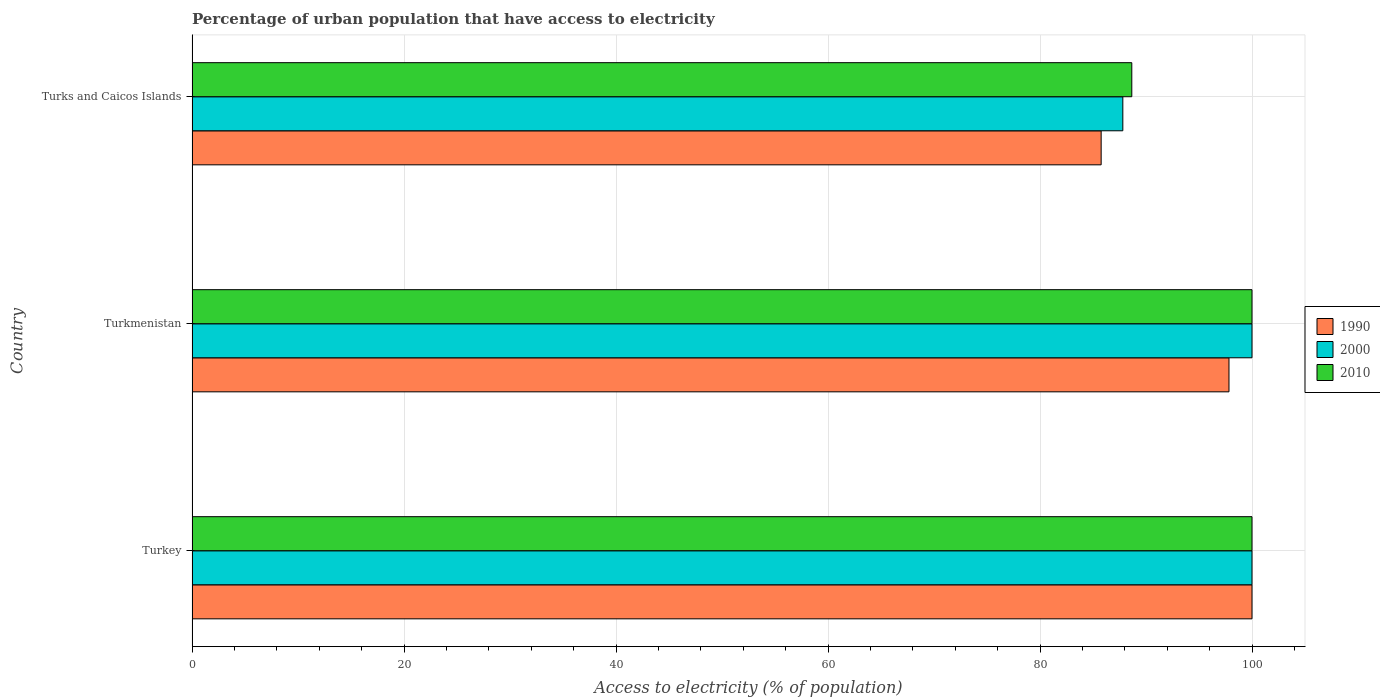How many different coloured bars are there?
Provide a short and direct response. 3. How many groups of bars are there?
Your answer should be very brief. 3. Are the number of bars per tick equal to the number of legend labels?
Provide a succinct answer. Yes. Are the number of bars on each tick of the Y-axis equal?
Offer a very short reply. Yes. How many bars are there on the 3rd tick from the top?
Provide a succinct answer. 3. How many bars are there on the 1st tick from the bottom?
Provide a short and direct response. 3. What is the label of the 1st group of bars from the top?
Your response must be concise. Turks and Caicos Islands. In how many cases, is the number of bars for a given country not equal to the number of legend labels?
Make the answer very short. 0. What is the percentage of urban population that have access to electricity in 1990 in Turks and Caicos Islands?
Your answer should be compact. 85.77. Across all countries, what is the maximum percentage of urban population that have access to electricity in 1990?
Provide a short and direct response. 100. Across all countries, what is the minimum percentage of urban population that have access to electricity in 2010?
Provide a succinct answer. 88.66. In which country was the percentage of urban population that have access to electricity in 2010 minimum?
Give a very brief answer. Turks and Caicos Islands. What is the total percentage of urban population that have access to electricity in 2010 in the graph?
Ensure brevity in your answer.  288.66. What is the difference between the percentage of urban population that have access to electricity in 1990 in Turkmenistan and that in Turks and Caicos Islands?
Your response must be concise. 12.06. What is the difference between the percentage of urban population that have access to electricity in 2000 in Turks and Caicos Islands and the percentage of urban population that have access to electricity in 1990 in Turkey?
Make the answer very short. -12.19. What is the average percentage of urban population that have access to electricity in 2010 per country?
Provide a succinct answer. 96.22. In how many countries, is the percentage of urban population that have access to electricity in 1990 greater than 12 %?
Keep it short and to the point. 3. What is the ratio of the percentage of urban population that have access to electricity in 2010 in Turkey to that in Turks and Caicos Islands?
Your response must be concise. 1.13. Is the difference between the percentage of urban population that have access to electricity in 2010 in Turkey and Turkmenistan greater than the difference between the percentage of urban population that have access to electricity in 2000 in Turkey and Turkmenistan?
Your answer should be compact. No. What is the difference between the highest and the lowest percentage of urban population that have access to electricity in 1990?
Keep it short and to the point. 14.23. Is it the case that in every country, the sum of the percentage of urban population that have access to electricity in 2000 and percentage of urban population that have access to electricity in 1990 is greater than the percentage of urban population that have access to electricity in 2010?
Ensure brevity in your answer.  Yes. How many bars are there?
Your answer should be very brief. 9. What is the difference between two consecutive major ticks on the X-axis?
Your answer should be very brief. 20. Does the graph contain grids?
Your answer should be compact. Yes. Where does the legend appear in the graph?
Offer a very short reply. Center right. What is the title of the graph?
Ensure brevity in your answer.  Percentage of urban population that have access to electricity. What is the label or title of the X-axis?
Keep it short and to the point. Access to electricity (% of population). What is the label or title of the Y-axis?
Offer a terse response. Country. What is the Access to electricity (% of population) in 2000 in Turkey?
Ensure brevity in your answer.  100. What is the Access to electricity (% of population) in 1990 in Turkmenistan?
Ensure brevity in your answer.  97.83. What is the Access to electricity (% of population) in 1990 in Turks and Caicos Islands?
Offer a terse response. 85.77. What is the Access to electricity (% of population) in 2000 in Turks and Caicos Islands?
Offer a terse response. 87.81. What is the Access to electricity (% of population) in 2010 in Turks and Caicos Islands?
Give a very brief answer. 88.66. Across all countries, what is the maximum Access to electricity (% of population) of 1990?
Give a very brief answer. 100. Across all countries, what is the minimum Access to electricity (% of population) of 1990?
Your answer should be very brief. 85.77. Across all countries, what is the minimum Access to electricity (% of population) of 2000?
Offer a very short reply. 87.81. Across all countries, what is the minimum Access to electricity (% of population) in 2010?
Make the answer very short. 88.66. What is the total Access to electricity (% of population) of 1990 in the graph?
Give a very brief answer. 283.6. What is the total Access to electricity (% of population) of 2000 in the graph?
Your answer should be very brief. 287.81. What is the total Access to electricity (% of population) in 2010 in the graph?
Keep it short and to the point. 288.66. What is the difference between the Access to electricity (% of population) in 1990 in Turkey and that in Turkmenistan?
Give a very brief answer. 2.17. What is the difference between the Access to electricity (% of population) in 2000 in Turkey and that in Turkmenistan?
Provide a succinct answer. 0. What is the difference between the Access to electricity (% of population) of 1990 in Turkey and that in Turks and Caicos Islands?
Your answer should be very brief. 14.23. What is the difference between the Access to electricity (% of population) in 2000 in Turkey and that in Turks and Caicos Islands?
Your answer should be very brief. 12.19. What is the difference between the Access to electricity (% of population) of 2010 in Turkey and that in Turks and Caicos Islands?
Provide a succinct answer. 11.34. What is the difference between the Access to electricity (% of population) in 1990 in Turkmenistan and that in Turks and Caicos Islands?
Offer a very short reply. 12.06. What is the difference between the Access to electricity (% of population) of 2000 in Turkmenistan and that in Turks and Caicos Islands?
Your answer should be very brief. 12.19. What is the difference between the Access to electricity (% of population) in 2010 in Turkmenistan and that in Turks and Caicos Islands?
Provide a short and direct response. 11.34. What is the difference between the Access to electricity (% of population) of 1990 in Turkey and the Access to electricity (% of population) of 2000 in Turks and Caicos Islands?
Provide a succinct answer. 12.19. What is the difference between the Access to electricity (% of population) in 1990 in Turkey and the Access to electricity (% of population) in 2010 in Turks and Caicos Islands?
Your answer should be very brief. 11.34. What is the difference between the Access to electricity (% of population) of 2000 in Turkey and the Access to electricity (% of population) of 2010 in Turks and Caicos Islands?
Provide a succinct answer. 11.34. What is the difference between the Access to electricity (% of population) in 1990 in Turkmenistan and the Access to electricity (% of population) in 2000 in Turks and Caicos Islands?
Offer a very short reply. 10.02. What is the difference between the Access to electricity (% of population) in 1990 in Turkmenistan and the Access to electricity (% of population) in 2010 in Turks and Caicos Islands?
Your response must be concise. 9.17. What is the difference between the Access to electricity (% of population) in 2000 in Turkmenistan and the Access to electricity (% of population) in 2010 in Turks and Caicos Islands?
Offer a very short reply. 11.34. What is the average Access to electricity (% of population) of 1990 per country?
Your answer should be very brief. 94.53. What is the average Access to electricity (% of population) in 2000 per country?
Your answer should be very brief. 95.94. What is the average Access to electricity (% of population) in 2010 per country?
Your answer should be compact. 96.22. What is the difference between the Access to electricity (% of population) of 1990 and Access to electricity (% of population) of 2000 in Turkey?
Make the answer very short. 0. What is the difference between the Access to electricity (% of population) of 2000 and Access to electricity (% of population) of 2010 in Turkey?
Your answer should be compact. 0. What is the difference between the Access to electricity (% of population) in 1990 and Access to electricity (% of population) in 2000 in Turkmenistan?
Make the answer very short. -2.17. What is the difference between the Access to electricity (% of population) of 1990 and Access to electricity (% of population) of 2010 in Turkmenistan?
Keep it short and to the point. -2.17. What is the difference between the Access to electricity (% of population) of 2000 and Access to electricity (% of population) of 2010 in Turkmenistan?
Your response must be concise. 0. What is the difference between the Access to electricity (% of population) of 1990 and Access to electricity (% of population) of 2000 in Turks and Caicos Islands?
Your answer should be very brief. -2.04. What is the difference between the Access to electricity (% of population) in 1990 and Access to electricity (% of population) in 2010 in Turks and Caicos Islands?
Offer a very short reply. -2.89. What is the difference between the Access to electricity (% of population) in 2000 and Access to electricity (% of population) in 2010 in Turks and Caicos Islands?
Offer a terse response. -0.85. What is the ratio of the Access to electricity (% of population) in 1990 in Turkey to that in Turkmenistan?
Offer a very short reply. 1.02. What is the ratio of the Access to electricity (% of population) of 2000 in Turkey to that in Turkmenistan?
Ensure brevity in your answer.  1. What is the ratio of the Access to electricity (% of population) in 2010 in Turkey to that in Turkmenistan?
Ensure brevity in your answer.  1. What is the ratio of the Access to electricity (% of population) in 1990 in Turkey to that in Turks and Caicos Islands?
Provide a succinct answer. 1.17. What is the ratio of the Access to electricity (% of population) of 2000 in Turkey to that in Turks and Caicos Islands?
Your answer should be very brief. 1.14. What is the ratio of the Access to electricity (% of population) of 2010 in Turkey to that in Turks and Caicos Islands?
Give a very brief answer. 1.13. What is the ratio of the Access to electricity (% of population) of 1990 in Turkmenistan to that in Turks and Caicos Islands?
Give a very brief answer. 1.14. What is the ratio of the Access to electricity (% of population) of 2000 in Turkmenistan to that in Turks and Caicos Islands?
Offer a very short reply. 1.14. What is the ratio of the Access to electricity (% of population) in 2010 in Turkmenistan to that in Turks and Caicos Islands?
Ensure brevity in your answer.  1.13. What is the difference between the highest and the second highest Access to electricity (% of population) of 1990?
Keep it short and to the point. 2.17. What is the difference between the highest and the second highest Access to electricity (% of population) of 2000?
Your answer should be very brief. 0. What is the difference between the highest and the lowest Access to electricity (% of population) in 1990?
Your response must be concise. 14.23. What is the difference between the highest and the lowest Access to electricity (% of population) of 2000?
Offer a very short reply. 12.19. What is the difference between the highest and the lowest Access to electricity (% of population) in 2010?
Offer a very short reply. 11.34. 